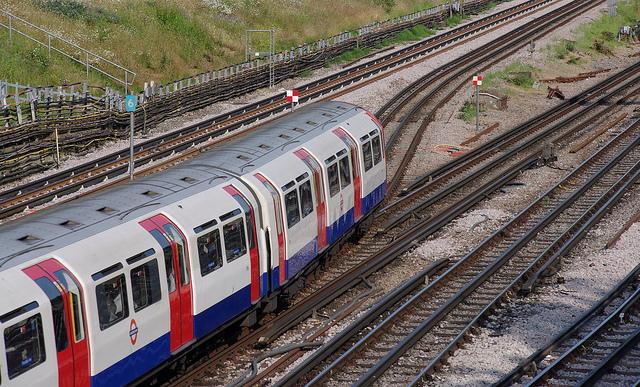Is this train accommodating to passengers?
Be succinct. Yes. Is there more than one track?
Write a very short answer. Yes. Does the train look like its turning in certain direction?
Answer briefly. Yes. Are there trees visible?
Keep it brief. No. 